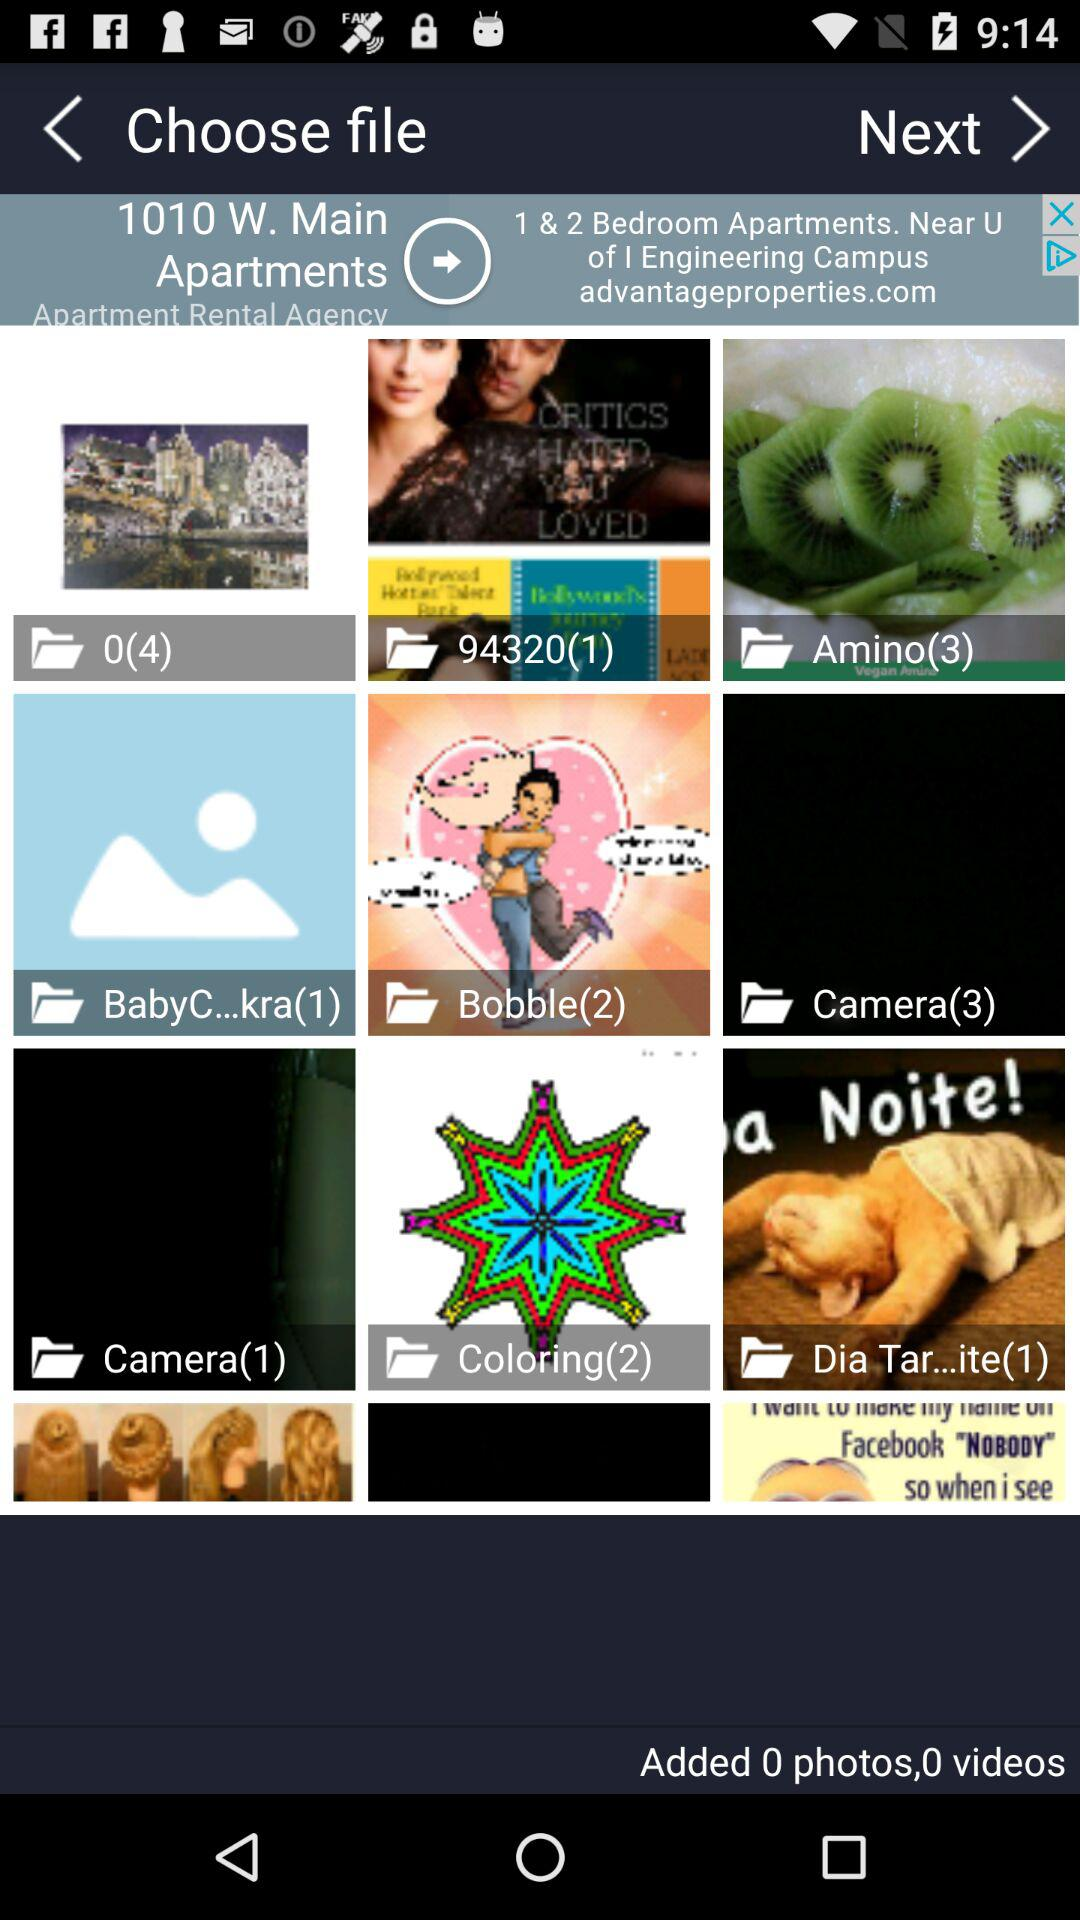What is the number of images in the "Amino" folder? The number of images in the "Amino" folder is 3. 